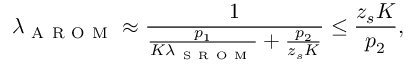<formula> <loc_0><loc_0><loc_500><loc_500>\lambda _ { A R O M } \approx \frac { 1 } { \frac { p _ { 1 } } { K \lambda _ { S R O M } } + \frac { p _ { 2 } } { z _ { s } K } } \leq \frac { z _ { s } K } { p _ { 2 } } ,</formula> 